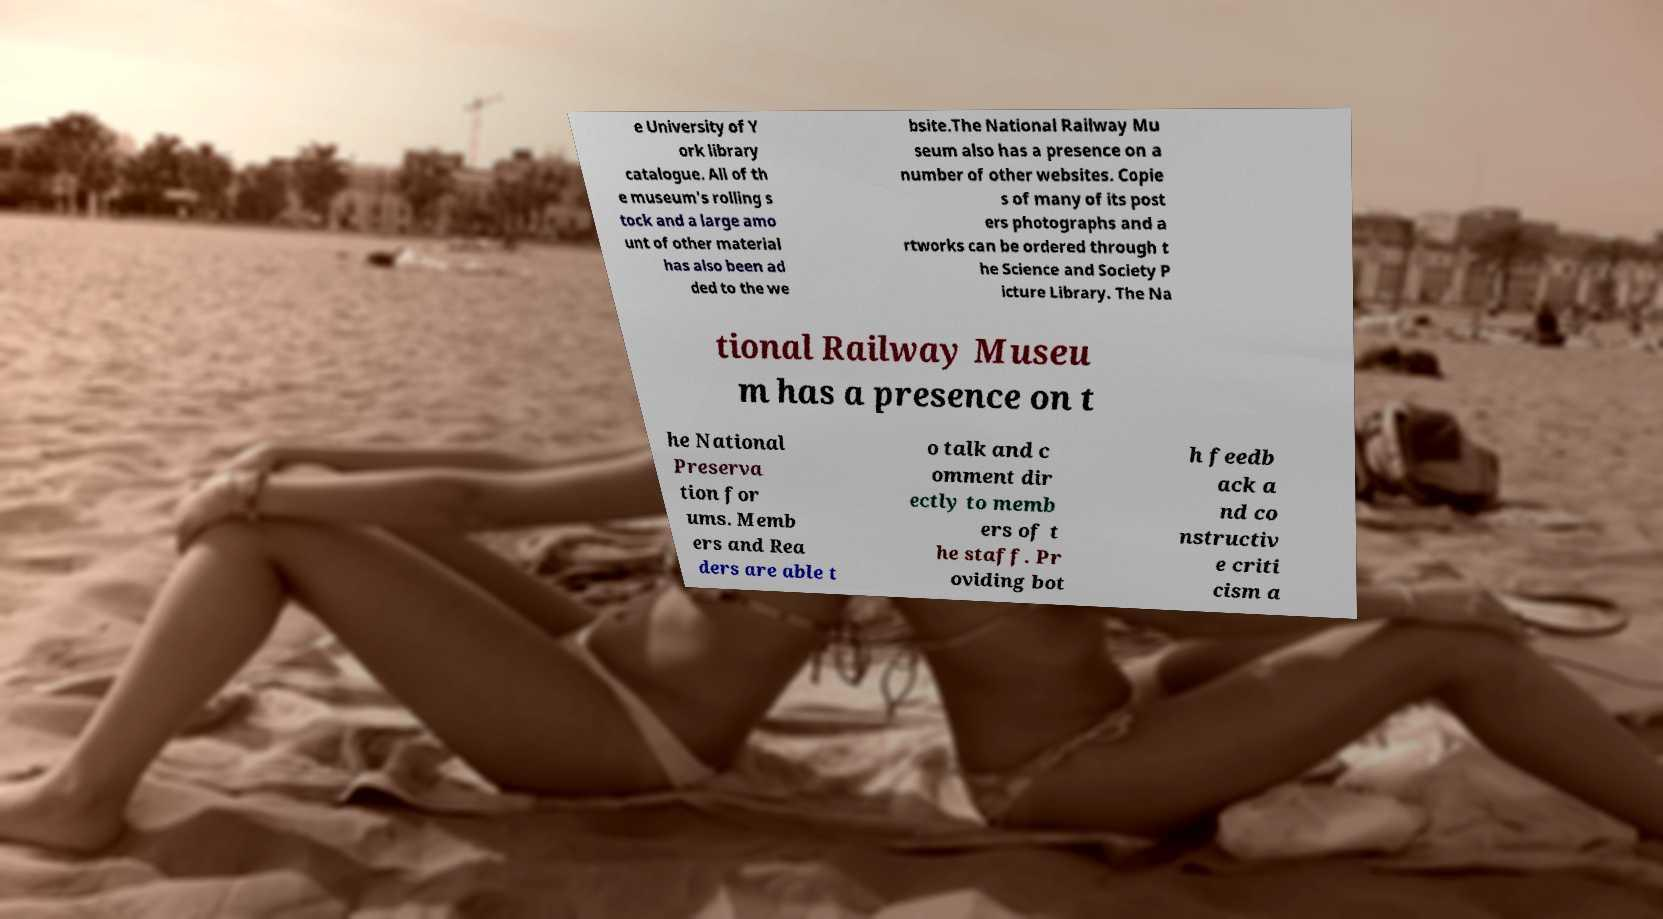Can you accurately transcribe the text from the provided image for me? e University of Y ork library catalogue. All of th e museum's rolling s tock and a large amo unt of other material has also been ad ded to the we bsite.The National Railway Mu seum also has a presence on a number of other websites. Copie s of many of its post ers photographs and a rtworks can be ordered through t he Science and Society P icture Library. The Na tional Railway Museu m has a presence on t he National Preserva tion for ums. Memb ers and Rea ders are able t o talk and c omment dir ectly to memb ers of t he staff. Pr oviding bot h feedb ack a nd co nstructiv e criti cism a 